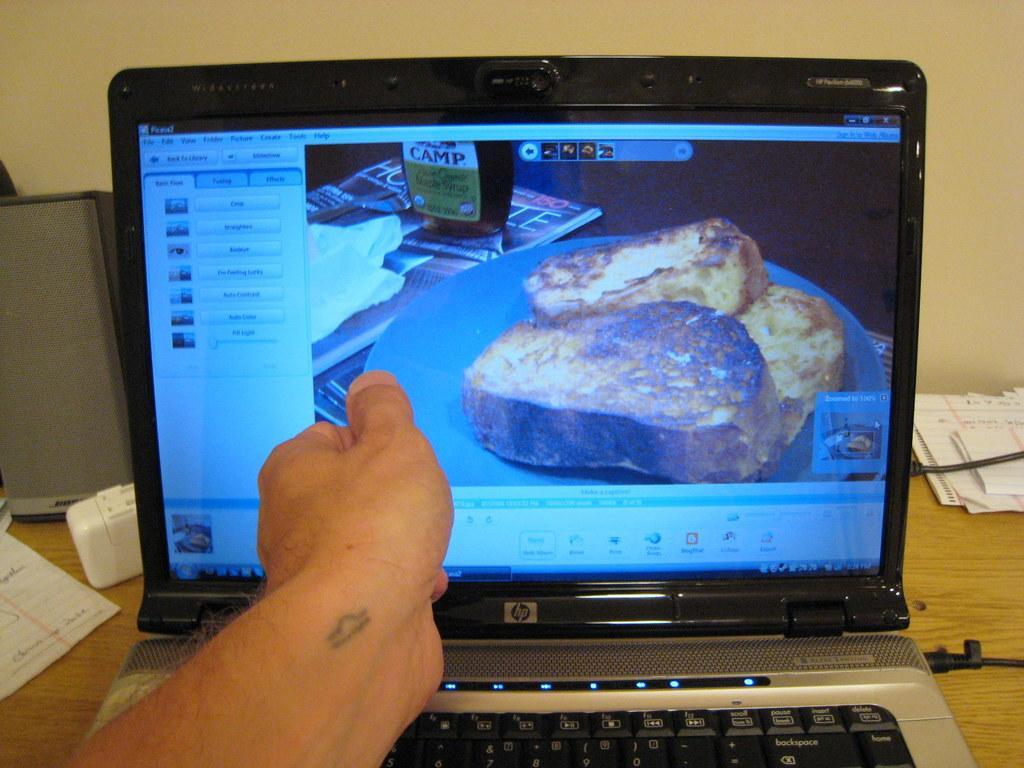Please provide a concise description of this image. This picture is clicked inside. In the foreground we can see the hand of a person. In the center there is a wooden table on the top of which we can see a laptop, speaker, papers and some other objects are placed and we can see the text and some pictures on the display of a laptop. In the background there is a wall. 